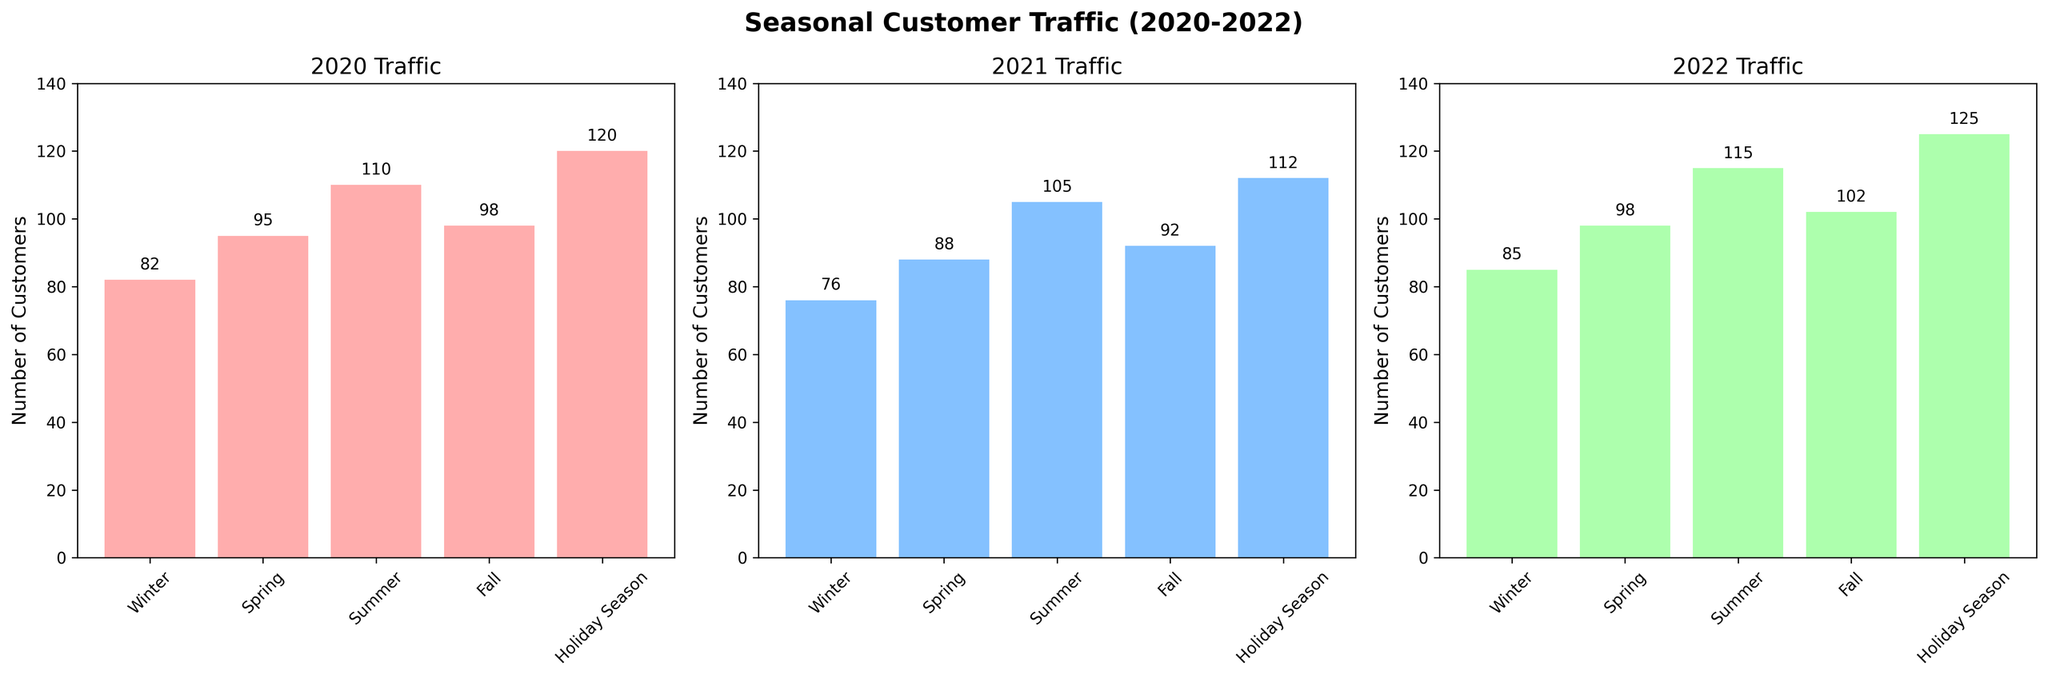Which season had the highest customer traffic in 2020? By observing the bar heights for 2020, the Holiday Season has the highest value at 120 customers.
Answer: Holiday Season Compare the customer traffic between Summer and Fall in 2021. Which season had more customers? Looking at the bar heights for 2021, Summer had 105 customers and Fall had 92 customers. Thus, Summer had more customers.
Answer: Summer What was the total number of customers in Spring across the three years? The number of customers in Spring was 95 in 2020, 88 in 2021, and 98 in 2022. Summing these values gives 95 + 88 + 98 = 281 customers.
Answer: 281 Which year had the lowest customer traffic in Winter? Comparing the Winter bars for all three years, 2021 had the lowest customer traffic with 76 customers.
Answer: 2021 What is the average number of customers during the Fall season over the three years? The number of customers during the Fall was 98 in 2020, 92 in 2021, and 102 in 2022. The average is calculated as (98 + 92 + 102) / 3 = 97.33 customers.
Answer: 97.33 In which year did the customer traffic in the Holiday Season exceed 120? Examining the Holiday Season bars, only the year 2022 had customer traffic exceeding 120, with a value of 125.
Answer: 2022 By how much did the customer traffic in Summer increase from 2020 to 2022? Customer traffic in Summer was 110 in 2020 and 115 in 2022. The increase is 115 - 110 = 5 customers.
Answer: 5 Which season saw the most consistent customer traffic over the three years? Observing the bars, Winter had relatively consistent customer traffic with values 82 in 2020, 76 in 2021, and 85 in 2022. Its absolute deviations are smaller compared to other seasons.
Answer: Winter What was the percentage increase in customer traffic for Spring from 2021 to 2022? Spring traffic increased from 88 in 2021 to 98 in 2022. The percentage increase is ((98 - 88) / 88) * 100% = 11.36%.
Answer: 11.36% 